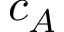Convert formula to latex. <formula><loc_0><loc_0><loc_500><loc_500>c _ { A }</formula> 